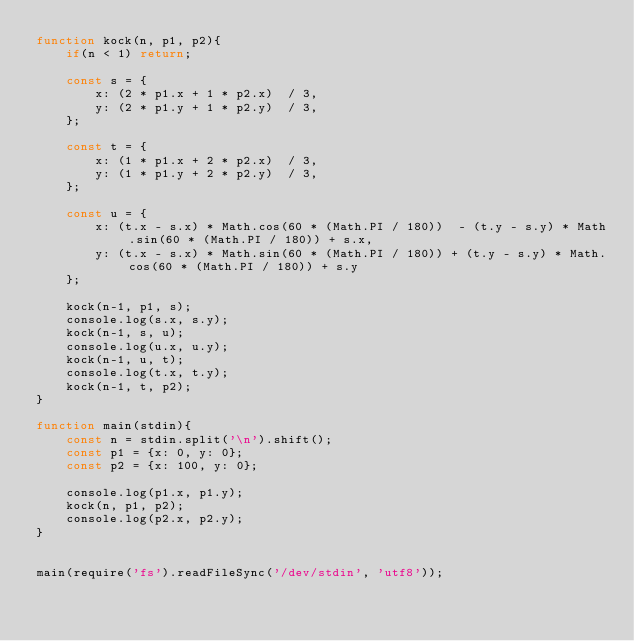<code> <loc_0><loc_0><loc_500><loc_500><_JavaScript_>function kock(n, p1, p2){
    if(n < 1) return;

    const s = {
        x: (2 * p1.x + 1 * p2.x)  / 3,
        y: (2 * p1.y + 1 * p2.y)  / 3,
    };

    const t = {
        x: (1 * p1.x + 2 * p2.x)  / 3,
        y: (1 * p1.y + 2 * p2.y)  / 3,
    };

    const u = {
        x: (t.x - s.x) * Math.cos(60 * (Math.PI / 180))  - (t.y - s.y) * Math.sin(60 * (Math.PI / 180)) + s.x,
        y: (t.x - s.x) * Math.sin(60 * (Math.PI / 180)) + (t.y - s.y) * Math.cos(60 * (Math.PI / 180)) + s.y
    };

    kock(n-1, p1, s);
    console.log(s.x, s.y);
    kock(n-1, s, u);
    console.log(u.x, u.y);
    kock(n-1, u, t);
    console.log(t.x, t.y);
    kock(n-1, t, p2);
}

function main(stdin){
    const n = stdin.split('\n').shift();
    const p1 = {x: 0, y: 0};
    const p2 = {x: 100, y: 0};

    console.log(p1.x, p1.y);
    kock(n, p1, p2);
    console.log(p2.x, p2.y);
}


main(require('fs').readFileSync('/dev/stdin', 'utf8'));

</code> 